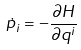<formula> <loc_0><loc_0><loc_500><loc_500>\dot { p } _ { i } = - { \frac { \partial H } { \partial q ^ { i } } }</formula> 